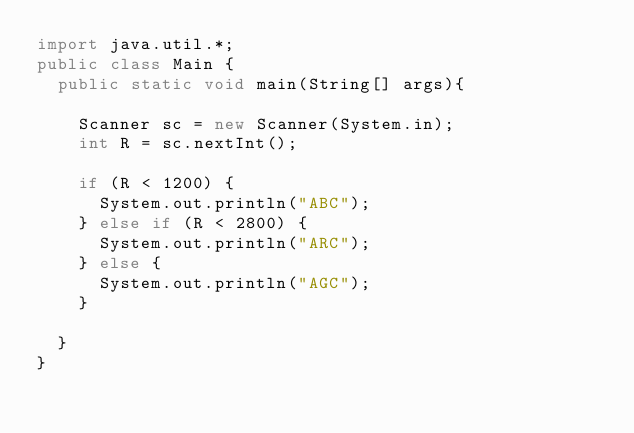<code> <loc_0><loc_0><loc_500><loc_500><_Java_>import java.util.*;
public class Main {
  public static void main(String[] args){

    Scanner sc = new Scanner(System.in);
    int R = sc.nextInt();

    if (R < 1200) {
      System.out.println("ABC");
    } else if (R < 2800) {
      System.out.println("ARC");
    } else {
      System.out.println("AGC");
    }

  }
}</code> 